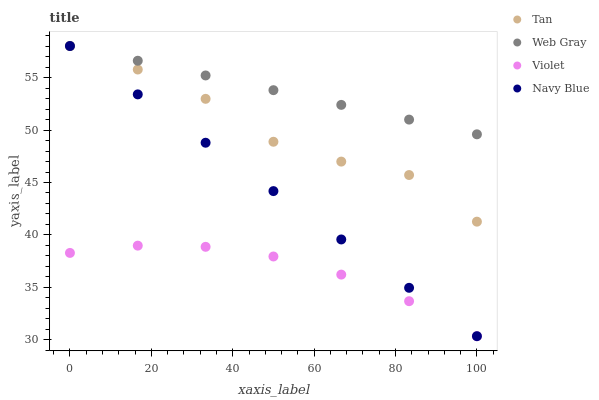Does Violet have the minimum area under the curve?
Answer yes or no. Yes. Does Web Gray have the maximum area under the curve?
Answer yes or no. Yes. Does Tan have the minimum area under the curve?
Answer yes or no. No. Does Tan have the maximum area under the curve?
Answer yes or no. No. Is Web Gray the smoothest?
Answer yes or no. Yes. Is Tan the roughest?
Answer yes or no. Yes. Is Tan the smoothest?
Answer yes or no. No. Is Web Gray the roughest?
Answer yes or no. No. Does Violet have the lowest value?
Answer yes or no. Yes. Does Tan have the lowest value?
Answer yes or no. No. Does Web Gray have the highest value?
Answer yes or no. Yes. Does Violet have the highest value?
Answer yes or no. No. Is Violet less than Tan?
Answer yes or no. Yes. Is Web Gray greater than Violet?
Answer yes or no. Yes. Does Navy Blue intersect Web Gray?
Answer yes or no. Yes. Is Navy Blue less than Web Gray?
Answer yes or no. No. Is Navy Blue greater than Web Gray?
Answer yes or no. No. Does Violet intersect Tan?
Answer yes or no. No. 